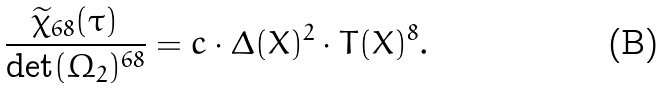Convert formula to latex. <formula><loc_0><loc_0><loc_500><loc_500>\frac { \widetilde { \chi } _ { 6 8 } ( \tau ) } { \det ( \Omega _ { 2 } ) ^ { 6 8 } } = c \cdot \Delta ( X ) ^ { 2 } \cdot T ( X ) ^ { 8 } .</formula> 